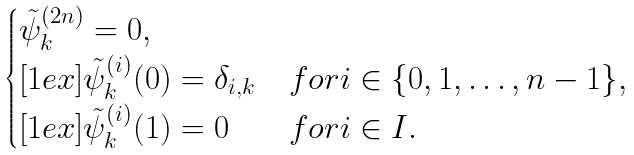Convert formula to latex. <formula><loc_0><loc_0><loc_500><loc_500>\begin{cases} \tilde { \psi } _ { k } ^ { ( 2 n ) } = 0 , \\ [ 1 e x ] \tilde { \psi } _ { k } ^ { ( i ) } ( 0 ) = \delta _ { i , k } & f o r i \in \{ 0 , 1 , \dots , n - 1 \} , \\ [ 1 e x ] \tilde { \psi } _ { k } ^ { ( i ) } ( 1 ) = 0 & f o r i \in I . \end{cases}</formula> 